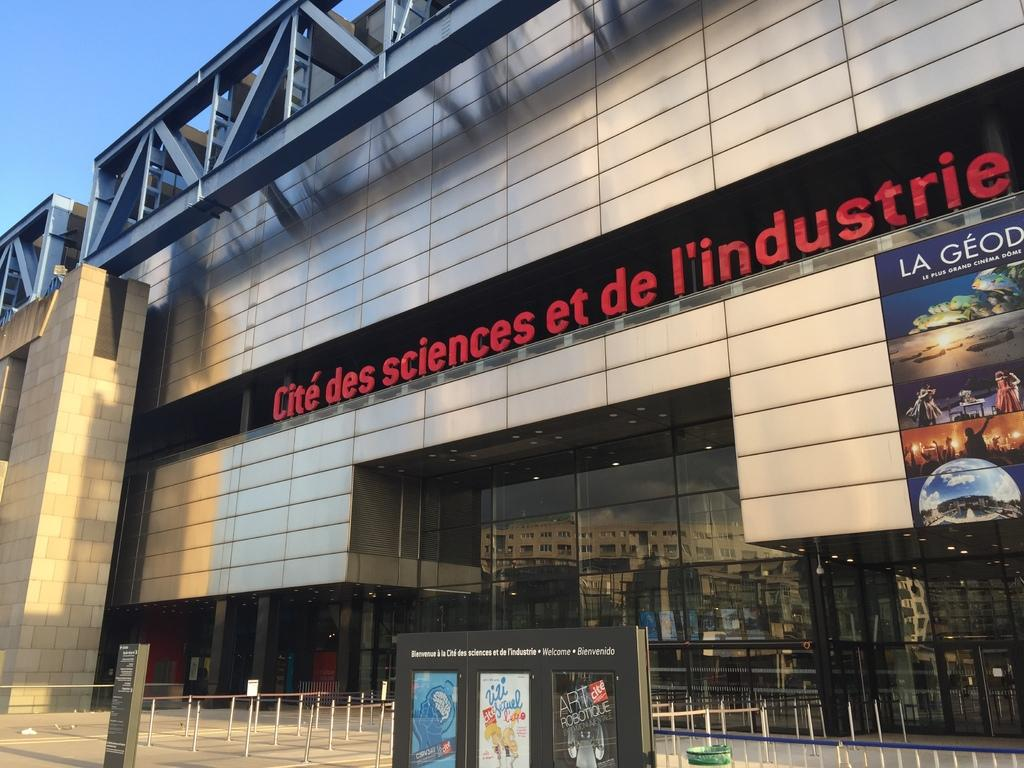Provide a one-sentence caption for the provided image. The front of the Cite des Sciences et de L'industrie building. 